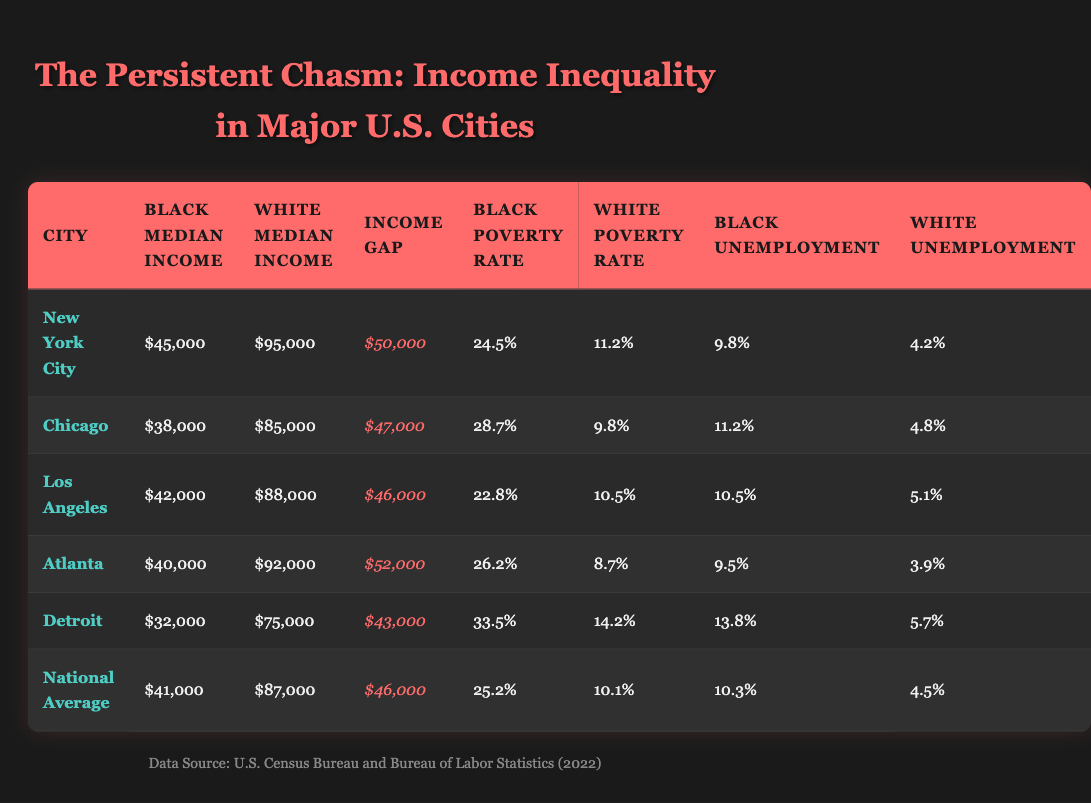What is the black median income in New York City? The black median income for New York City is stated directly in the table as $45,000.
Answer: $45,000 What is the income gap between black and white households in Chicago? For Chicago, the black median income is $38,000 and the white median income is $85,000. The income gap is calculated by subtracting the black median income from the white median income: $85,000 - $38,000 = $47,000.
Answer: $47,000 Is the poverty rate among black households higher than among white households in Atlanta? The black poverty rate in Atlanta is 26.2%, while the white poverty rate is 8.7%. Since 26.2% is greater than 8.7%, the answer is yes.
Answer: Yes Which city has the highest black unemployment rate? The black unemployment rates are: New York City (9.8%), Chicago (11.2%), Los Angeles (10.5%), Atlanta (9.5%), and Detroit (13.8%). Comparing these values, Detroit has the highest rate at 13.8%.
Answer: Detroit What is the average black median income across all cities listed? The black median incomes are: $45,000 (New York City), $38,000 (Chicago), $42,000 (Los Angeles), $40,000 (Atlanta), and $32,000 (Detroit). To calculate the average, sum these values: $45,000 + $38,000 + $42,000 + $40,000 + $32,000 = $197,000. Then divide by 5: $197,000 / 5 = $39,400.
Answer: $39,400 In which city do black households face the highest poverty rate? The black poverty rates are: 24.5% (New York City), 28.7% (Chicago), 22.8% (Los Angeles), 26.2% (Atlanta), and 33.5% (Detroit). Detroit has the highest rate at 33.5%.
Answer: Detroit Is the white median income in Los Angeles greater than the national average white median income? The white median income in Los Angeles is reported as $88,000, while the national average white median income is $87,000. Since $88,000 is greater than $87,000, the answer is yes.
Answer: Yes What is the difference in poverty rates between black and white households in Detroit? In Detroit, the black poverty rate is 33.5% and the white poverty rate is 14.2%. The difference is calculated as 33.5% - 14.2% = 19.3%.
Answer: 19.3% Which city shows the largest income gap between black and white households? To find the largest income gap, compare the income gaps from each city: New York City ($50,000), Chicago ($47,000), Los Angeles ($46,000), Atlanta ($52,000), and Detroit ($43,000). The largest gap is in New York City with $50,000.
Answer: New York City 